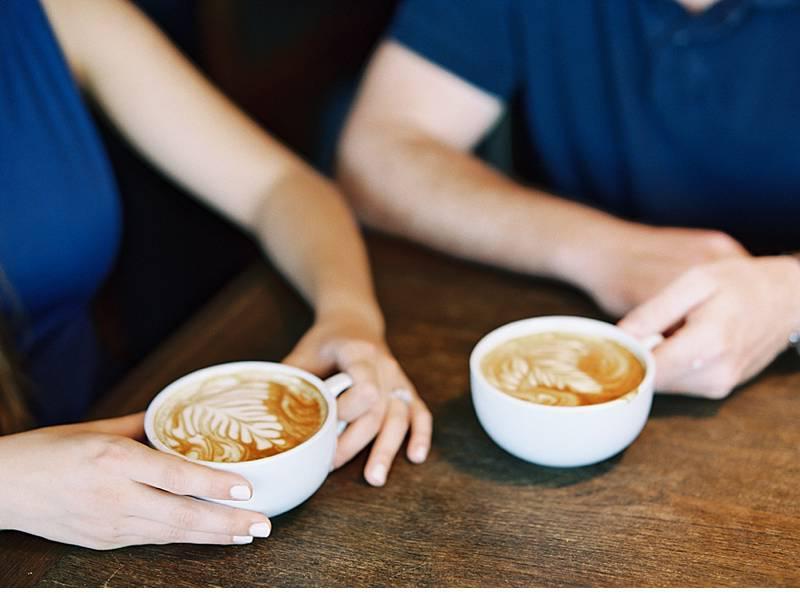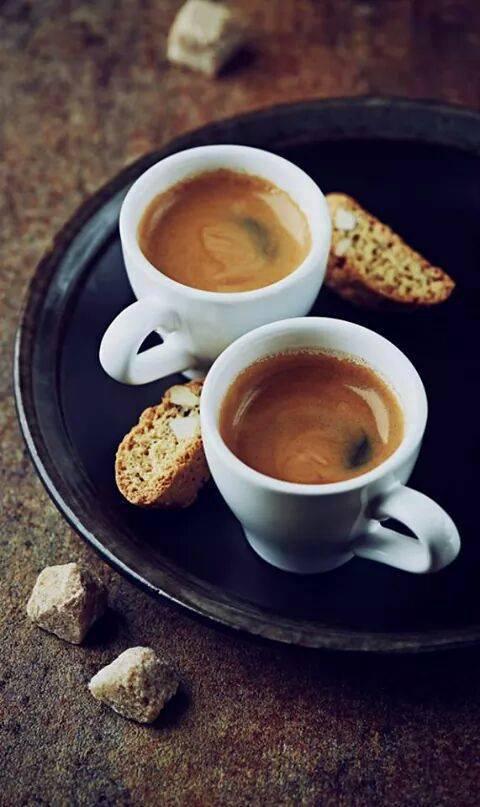The first image is the image on the left, the second image is the image on the right. For the images shown, is this caption "At least one image shows a pair of filled cups with silver spoons nearby." true? Answer yes or no. No. The first image is the image on the left, the second image is the image on the right. Given the left and right images, does the statement "Two white cups sit on saucers on a wooden table." hold true? Answer yes or no. No. 